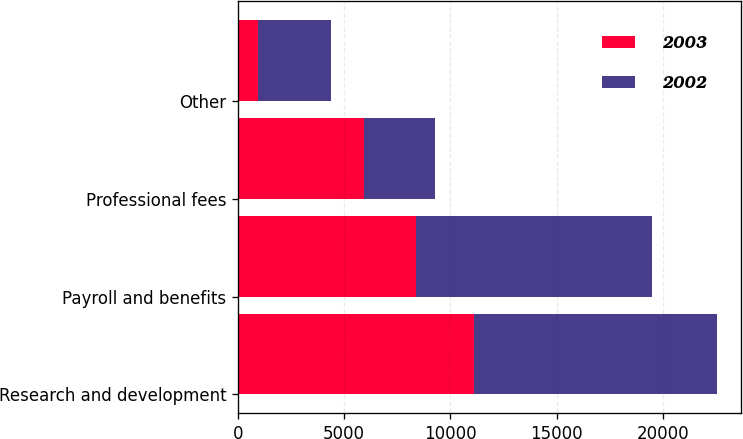Convert chart. <chart><loc_0><loc_0><loc_500><loc_500><stacked_bar_chart><ecel><fcel>Research and development<fcel>Payroll and benefits<fcel>Professional fees<fcel>Other<nl><fcel>2003<fcel>11098<fcel>8399<fcel>5940<fcel>937<nl><fcel>2002<fcel>11435<fcel>11100<fcel>3324<fcel>3447<nl></chart> 